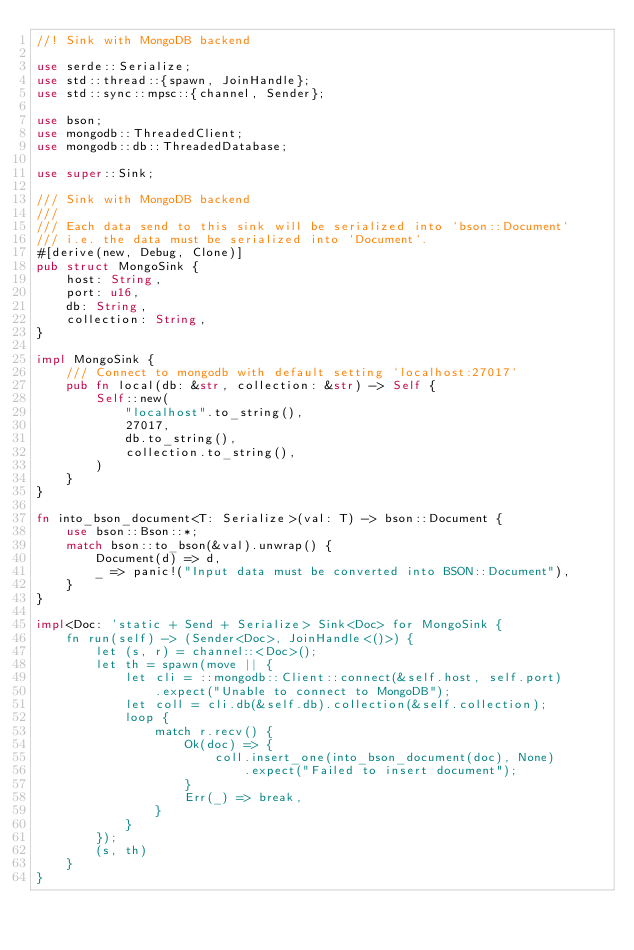<code> <loc_0><loc_0><loc_500><loc_500><_Rust_>//! Sink with MongoDB backend

use serde::Serialize;
use std::thread::{spawn, JoinHandle};
use std::sync::mpsc::{channel, Sender};

use bson;
use mongodb::ThreadedClient;
use mongodb::db::ThreadedDatabase;

use super::Sink;

/// Sink with MongoDB backend
///
/// Each data send to this sink will be serialized into `bson::Document`
/// i.e. the data must be serialized into `Document`.
#[derive(new, Debug, Clone)]
pub struct MongoSink {
    host: String,
    port: u16,
    db: String,
    collection: String,
}

impl MongoSink {
    /// Connect to mongodb with default setting `localhost:27017`
    pub fn local(db: &str, collection: &str) -> Self {
        Self::new(
            "localhost".to_string(),
            27017,
            db.to_string(),
            collection.to_string(),
        )
    }
}

fn into_bson_document<T: Serialize>(val: T) -> bson::Document {
    use bson::Bson::*;
    match bson::to_bson(&val).unwrap() {
        Document(d) => d,
        _ => panic!("Input data must be converted into BSON::Document"),
    }
}

impl<Doc: 'static + Send + Serialize> Sink<Doc> for MongoSink {
    fn run(self) -> (Sender<Doc>, JoinHandle<()>) {
        let (s, r) = channel::<Doc>();
        let th = spawn(move || {
            let cli = ::mongodb::Client::connect(&self.host, self.port)
                .expect("Unable to connect to MongoDB");
            let coll = cli.db(&self.db).collection(&self.collection);
            loop {
                match r.recv() {
                    Ok(doc) => {
                        coll.insert_one(into_bson_document(doc), None)
                            .expect("Failed to insert document");
                    }
                    Err(_) => break,
                }
            }
        });
        (s, th)
    }
}
</code> 